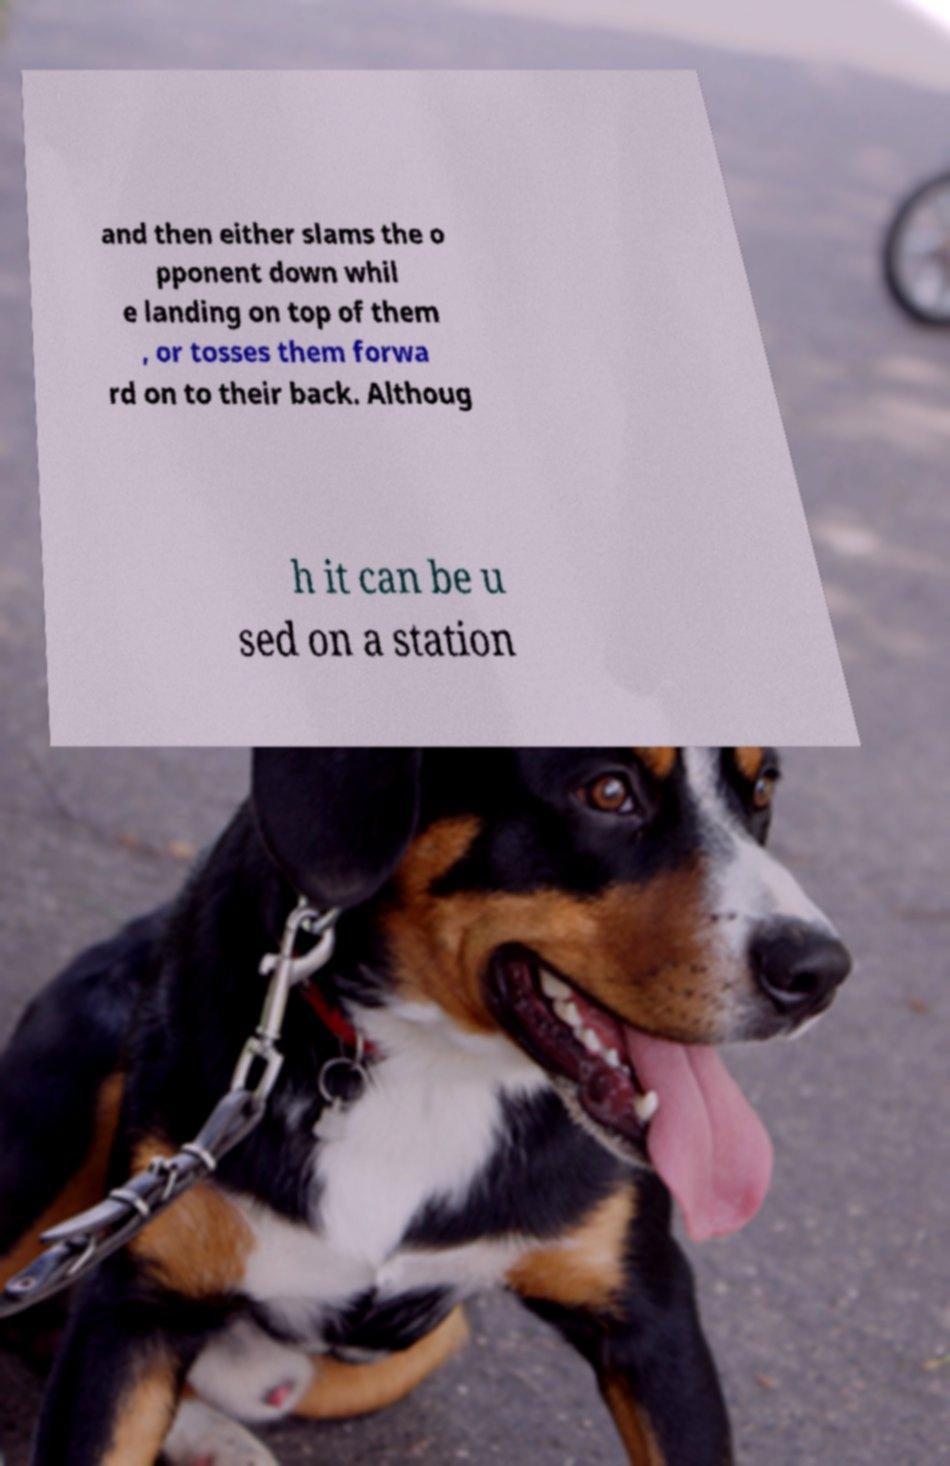For documentation purposes, I need the text within this image transcribed. Could you provide that? and then either slams the o pponent down whil e landing on top of them , or tosses them forwa rd on to their back. Althoug h it can be u sed on a station 